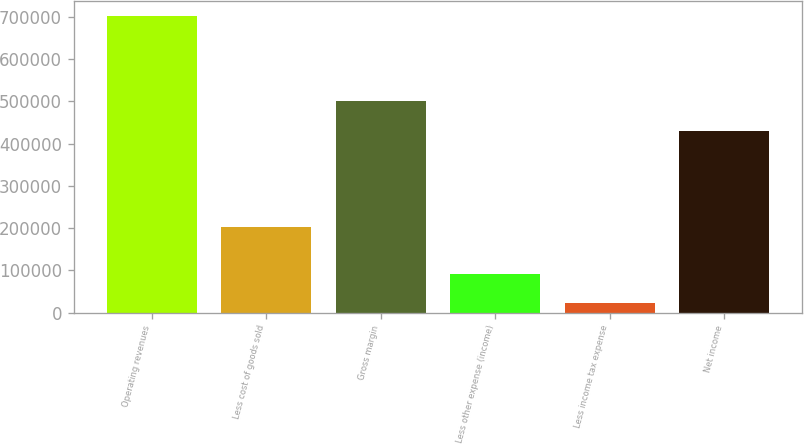Convert chart. <chart><loc_0><loc_0><loc_500><loc_500><bar_chart><fcel>Operating revenues<fcel>Less cost of goods sold<fcel>Gross margin<fcel>Less other expense (income)<fcel>Less income tax expense<fcel>Net income<nl><fcel>702556<fcel>202304<fcel>500252<fcel>91361.5<fcel>23451<fcel>429314<nl></chart> 